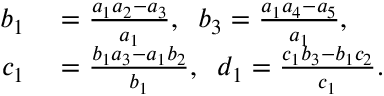Convert formula to latex. <formula><loc_0><loc_0><loc_500><loc_500>\begin{array} { r l } { b _ { 1 } } & = \frac { a _ { 1 } a _ { 2 } - a _ { 3 } } { a _ { 1 } } , \, b _ { 3 } = \frac { a _ { 1 } a _ { 4 } - a _ { 5 } } { a _ { 1 } } , } \\ { c _ { 1 } } & = \frac { b _ { 1 } a _ { 3 } - a _ { 1 } b _ { 2 } } { b _ { 1 } } , \, d _ { 1 } = \frac { c _ { 1 } b _ { 3 } - b _ { 1 } c _ { 2 } } { c _ { 1 } } . } \end{array}</formula> 